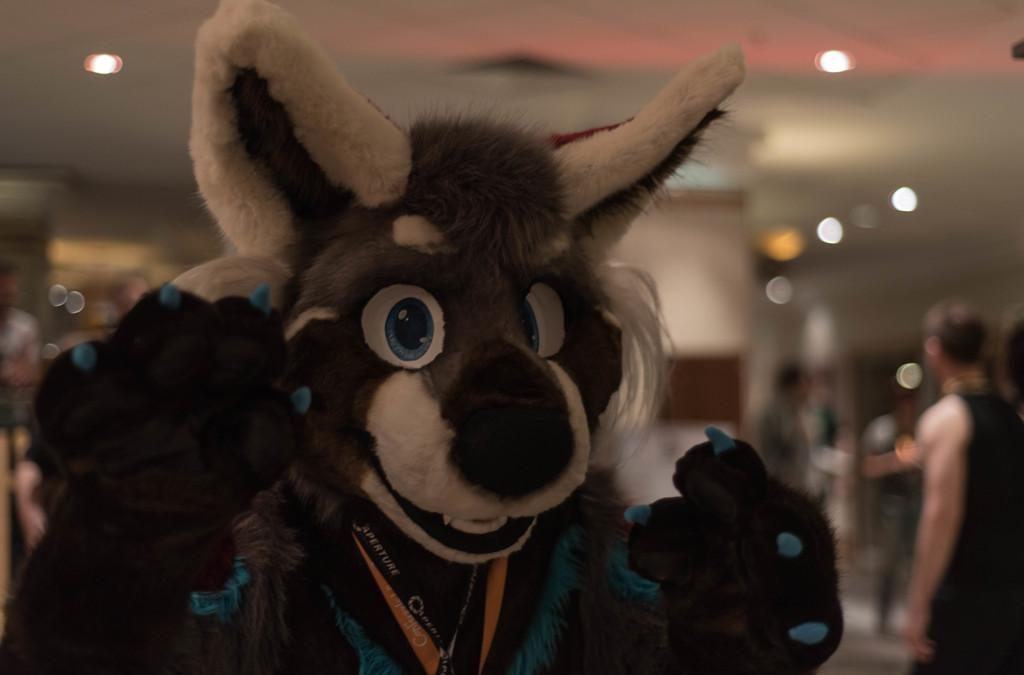What is the main subject in the image? There is a mascot in the image. Can you describe the background of the image? The background of the image is blurry. What can be seen on the roof top? There are lights on the roof top. What is happening on the floor in the image? There are people standing on the floor. What type of religion is being practiced by the mascot in the image? There is no indication of any religious practice in the image, as it features a mascot and other elements. How does the beef appear in the image? There is no beef present in the image. 